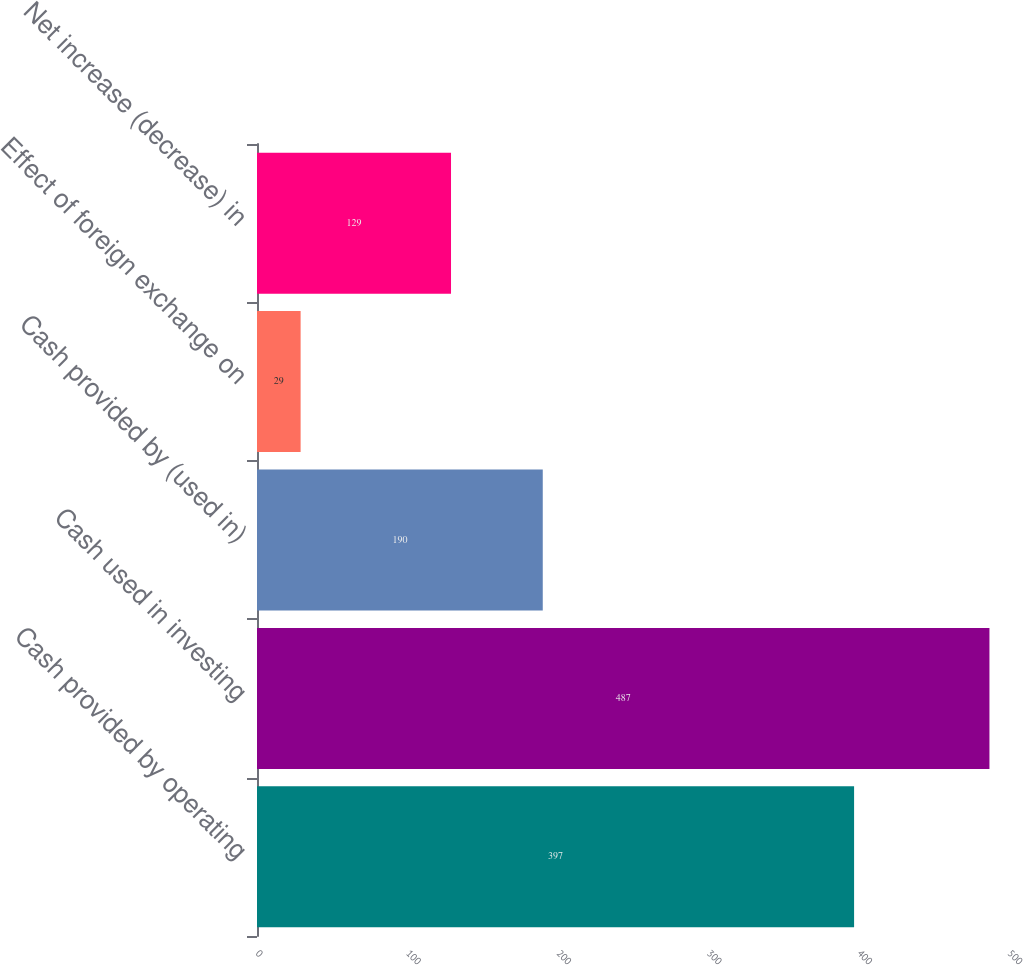Convert chart. <chart><loc_0><loc_0><loc_500><loc_500><bar_chart><fcel>Cash provided by operating<fcel>Cash used in investing<fcel>Cash provided by (used in)<fcel>Effect of foreign exchange on<fcel>Net increase (decrease) in<nl><fcel>397<fcel>487<fcel>190<fcel>29<fcel>129<nl></chart> 